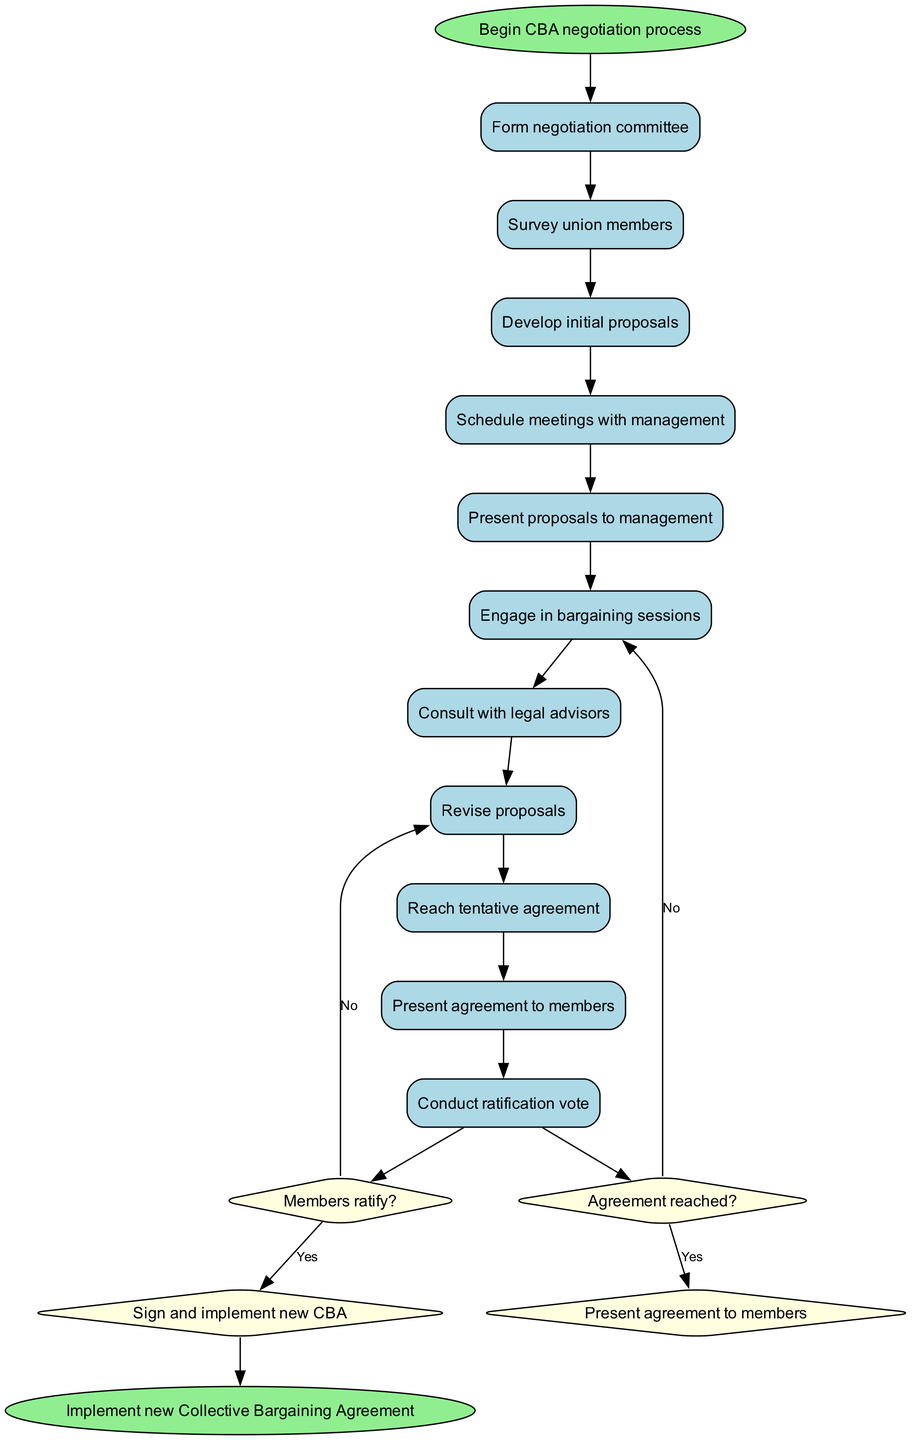What is the first activity in the negotiation process? The first activity listed in the diagram is "Form negotiation committee". This can be identified as the first node after the start node, which initiates the sequence of activities.
Answer: Form negotiation committee How many activities are involved in the negotiation process? There are ten activities outlined in the diagram. We count each item listed under "activities" to determine the total.
Answer: 10 What happens if the members do not ratify the agreement? If the members do not ratify the agreement, the process returns to "Return to bargaining table" as indicated by the decision path taken if the answer is "No".
Answer: Return to bargaining table What is the end node of the diagram? The end node is "Implement new Collective Bargaining Agreement". This is the last node leading from the final decision node when the agreement is ratified.
Answer: Implement new Collective Bargaining Agreement What is the decision made after the bargaining sessions? After the bargaining sessions, the decision made is whether an "Agreement reached?". This determines if the process continues or moves towards presenting the agreement.
Answer: Agreement reached? If a tentative agreement is reached, what is the next step? If a tentative agreement is reached, the next step is to "Present agreement to members", following the yes branch from the decision node.
Answer: Present agreement to members How do you transition from developing proposals to presenting them? You transition from "Develop initial proposals" to "Present proposals to management" through a direct edge connecting these two activities in the diagram.
Answer: Present proposals to management What happens after engaging in bargaining sessions if an agreement is not reached? If an agreement is not reached after engaging in bargaining sessions, the process continues with more "bargaining sessions" as indicated in the diagram.
Answer: Continue bargaining sessions 